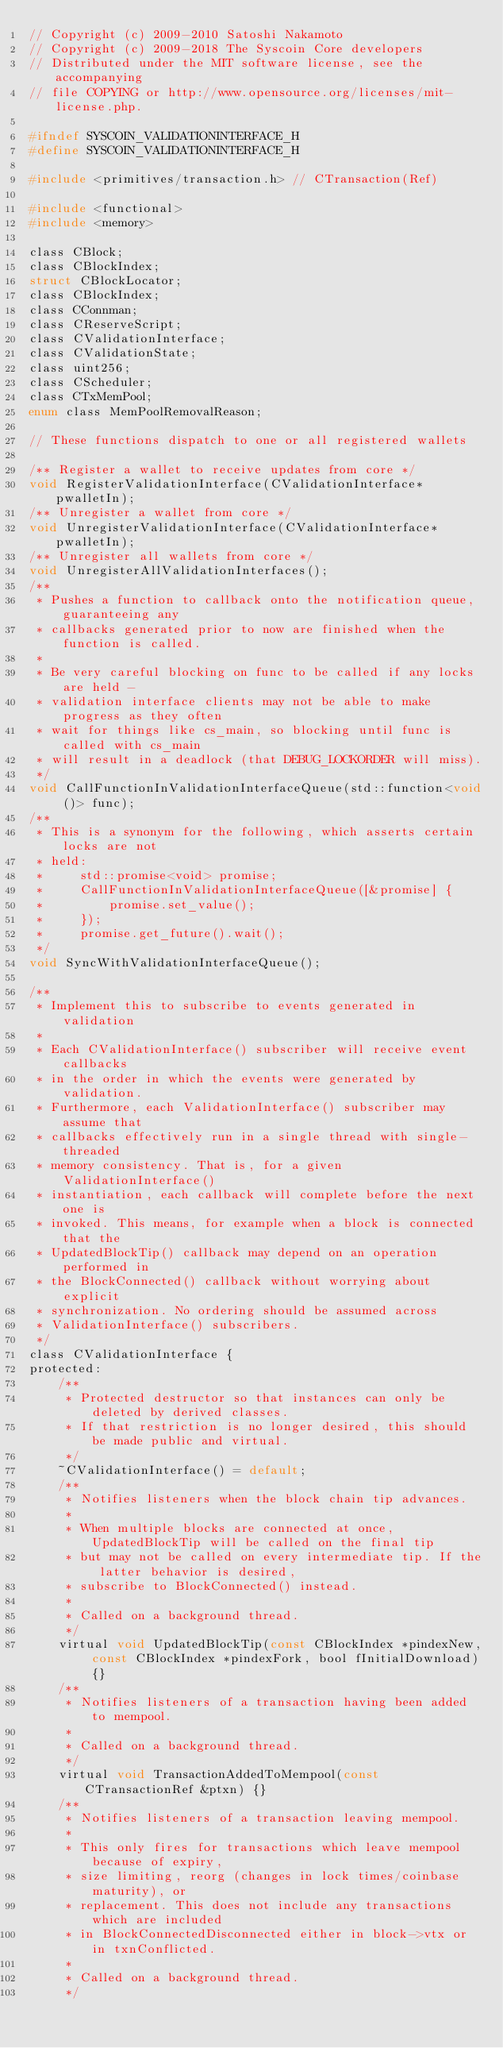Convert code to text. <code><loc_0><loc_0><loc_500><loc_500><_C_>// Copyright (c) 2009-2010 Satoshi Nakamoto
// Copyright (c) 2009-2018 The Syscoin Core developers
// Distributed under the MIT software license, see the accompanying
// file COPYING or http://www.opensource.org/licenses/mit-license.php.

#ifndef SYSCOIN_VALIDATIONINTERFACE_H
#define SYSCOIN_VALIDATIONINTERFACE_H

#include <primitives/transaction.h> // CTransaction(Ref)

#include <functional>
#include <memory>

class CBlock;
class CBlockIndex;
struct CBlockLocator;
class CBlockIndex;
class CConnman;
class CReserveScript;
class CValidationInterface;
class CValidationState;
class uint256;
class CScheduler;
class CTxMemPool;
enum class MemPoolRemovalReason;

// These functions dispatch to one or all registered wallets

/** Register a wallet to receive updates from core */
void RegisterValidationInterface(CValidationInterface* pwalletIn);
/** Unregister a wallet from core */
void UnregisterValidationInterface(CValidationInterface* pwalletIn);
/** Unregister all wallets from core */
void UnregisterAllValidationInterfaces();
/**
 * Pushes a function to callback onto the notification queue, guaranteeing any
 * callbacks generated prior to now are finished when the function is called.
 *
 * Be very careful blocking on func to be called if any locks are held -
 * validation interface clients may not be able to make progress as they often
 * wait for things like cs_main, so blocking until func is called with cs_main
 * will result in a deadlock (that DEBUG_LOCKORDER will miss).
 */
void CallFunctionInValidationInterfaceQueue(std::function<void ()> func);
/**
 * This is a synonym for the following, which asserts certain locks are not
 * held:
 *     std::promise<void> promise;
 *     CallFunctionInValidationInterfaceQueue([&promise] {
 *         promise.set_value();
 *     });
 *     promise.get_future().wait();
 */
void SyncWithValidationInterfaceQueue();

/**
 * Implement this to subscribe to events generated in validation
 *
 * Each CValidationInterface() subscriber will receive event callbacks
 * in the order in which the events were generated by validation.
 * Furthermore, each ValidationInterface() subscriber may assume that
 * callbacks effectively run in a single thread with single-threaded
 * memory consistency. That is, for a given ValidationInterface()
 * instantiation, each callback will complete before the next one is
 * invoked. This means, for example when a block is connected that the
 * UpdatedBlockTip() callback may depend on an operation performed in
 * the BlockConnected() callback without worrying about explicit
 * synchronization. No ordering should be assumed across
 * ValidationInterface() subscribers.
 */
class CValidationInterface {
protected:
    /**
     * Protected destructor so that instances can only be deleted by derived classes.
     * If that restriction is no longer desired, this should be made public and virtual.
     */
    ~CValidationInterface() = default;
    /**
     * Notifies listeners when the block chain tip advances.
     *
     * When multiple blocks are connected at once, UpdatedBlockTip will be called on the final tip
     * but may not be called on every intermediate tip. If the latter behavior is desired,
     * subscribe to BlockConnected() instead.
     *
     * Called on a background thread.
     */
    virtual void UpdatedBlockTip(const CBlockIndex *pindexNew, const CBlockIndex *pindexFork, bool fInitialDownload) {}
    /**
     * Notifies listeners of a transaction having been added to mempool.
     *
     * Called on a background thread.
     */
    virtual void TransactionAddedToMempool(const CTransactionRef &ptxn) {}
    /**
     * Notifies listeners of a transaction leaving mempool.
     *
     * This only fires for transactions which leave mempool because of expiry,
     * size limiting, reorg (changes in lock times/coinbase maturity), or
     * replacement. This does not include any transactions which are included
     * in BlockConnectedDisconnected either in block->vtx or in txnConflicted.
     *
     * Called on a background thread.
     */</code> 